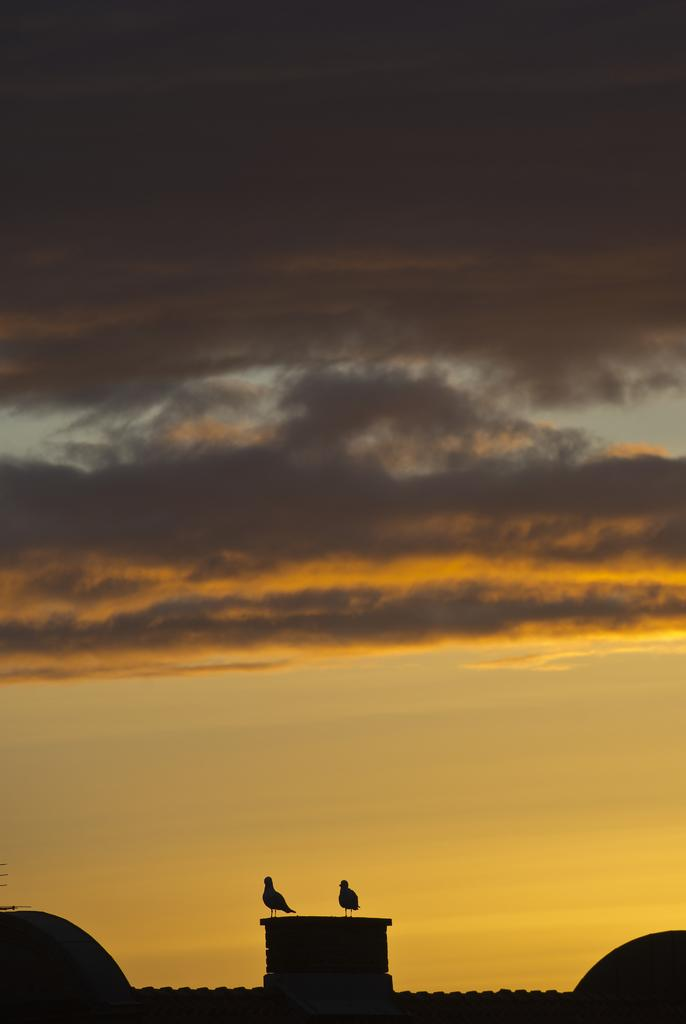How many birds are present in the image? There are two birds in the image. Where are the birds located? The birds are on the wall of a building. What can be seen in the background of the image? There is a sky visible in the background of the image. What type of corn is growing on the wall next to the birds in the image? There is no corn present in the image; it features two birds on the wall of a building. Can you see a snake slithering near the birds in the image? There is no snake present in the image; it only features two birds on the wall of a building. 